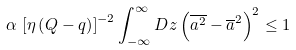<formula> <loc_0><loc_0><loc_500><loc_500>\alpha \, \left [ \eta \left ( Q - q \right ) \right ] ^ { - 2 } \int _ { - \infty } ^ { \infty } D z \left ( { \overline { a ^ { 2 } } } - { \overline { a } } ^ { 2 } \right ) ^ { 2 } \leq 1</formula> 